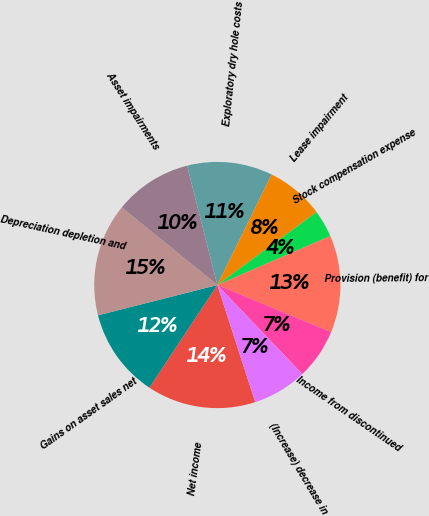Convert chart. <chart><loc_0><loc_0><loc_500><loc_500><pie_chart><fcel>Net income<fcel>Gains on asset sales net<fcel>Depreciation depletion and<fcel>Asset impairments<fcel>Exploratory dry hole costs<fcel>Lease impairment<fcel>Stock compensation expense<fcel>Provision (benefit) for<fcel>Income from discontinued<fcel>(Increase) decrease in<nl><fcel>14.29%<fcel>11.73%<fcel>14.8%<fcel>10.2%<fcel>11.22%<fcel>7.65%<fcel>3.57%<fcel>12.75%<fcel>6.63%<fcel>7.14%<nl></chart> 